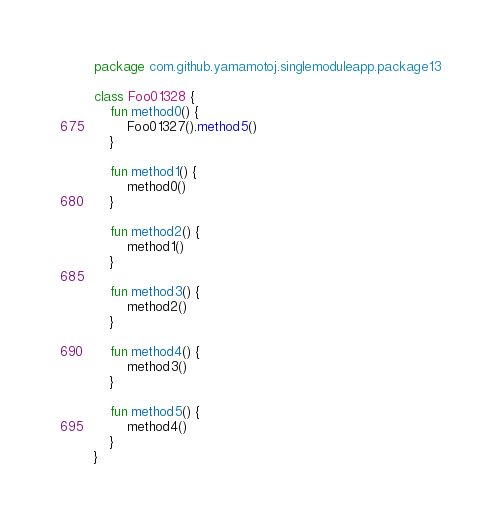<code> <loc_0><loc_0><loc_500><loc_500><_Kotlin_>package com.github.yamamotoj.singlemoduleapp.package13

class Foo01328 {
    fun method0() {
        Foo01327().method5()
    }

    fun method1() {
        method0()
    }

    fun method2() {
        method1()
    }

    fun method3() {
        method2()
    }

    fun method4() {
        method3()
    }

    fun method5() {
        method4()
    }
}
</code> 